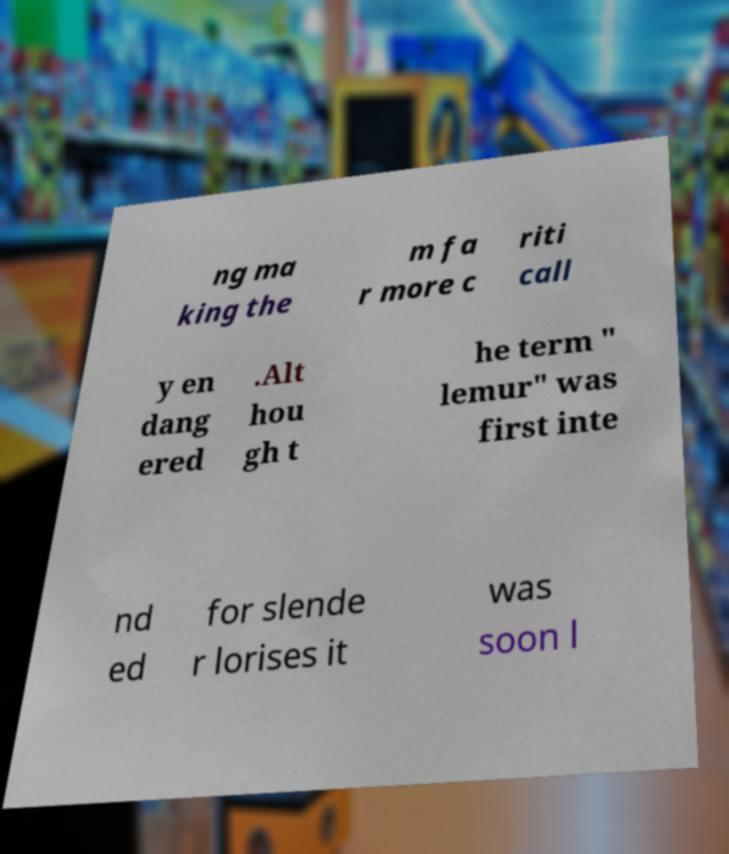Can you read and provide the text displayed in the image?This photo seems to have some interesting text. Can you extract and type it out for me? ng ma king the m fa r more c riti call y en dang ered .Alt hou gh t he term " lemur" was first inte nd ed for slende r lorises it was soon l 